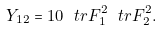Convert formula to latex. <formula><loc_0><loc_0><loc_500><loc_500>Y _ { 1 2 } = 1 0 \ t r F _ { 1 } ^ { 2 } \ t r F _ { 2 } ^ { 2 } .</formula> 